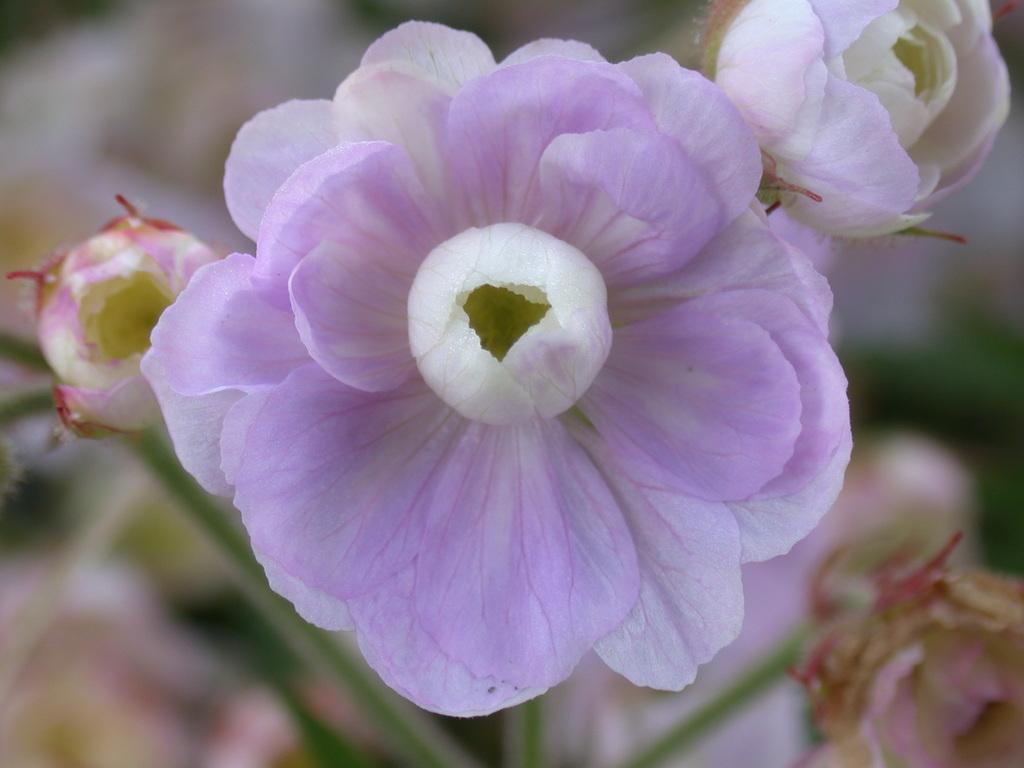Can you describe this image briefly? In this picture we can see few flowers and blurry background. 